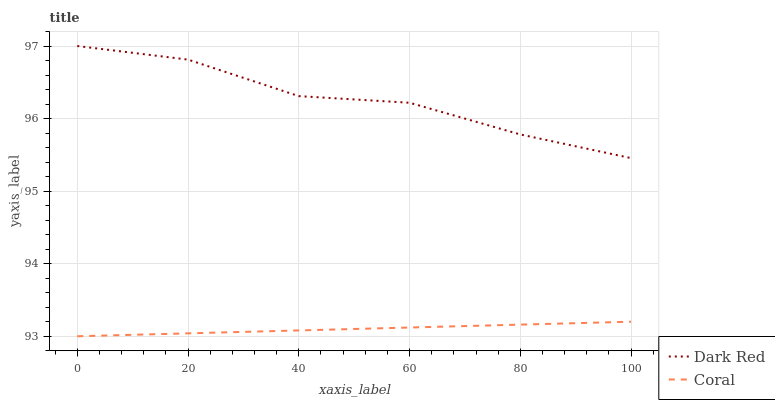Does Coral have the minimum area under the curve?
Answer yes or no. Yes. Does Dark Red have the maximum area under the curve?
Answer yes or no. Yes. Does Coral have the maximum area under the curve?
Answer yes or no. No. Is Coral the smoothest?
Answer yes or no. Yes. Is Dark Red the roughest?
Answer yes or no. Yes. Is Coral the roughest?
Answer yes or no. No. Does Coral have the lowest value?
Answer yes or no. Yes. Does Dark Red have the highest value?
Answer yes or no. Yes. Does Coral have the highest value?
Answer yes or no. No. Is Coral less than Dark Red?
Answer yes or no. Yes. Is Dark Red greater than Coral?
Answer yes or no. Yes. Does Coral intersect Dark Red?
Answer yes or no. No. 